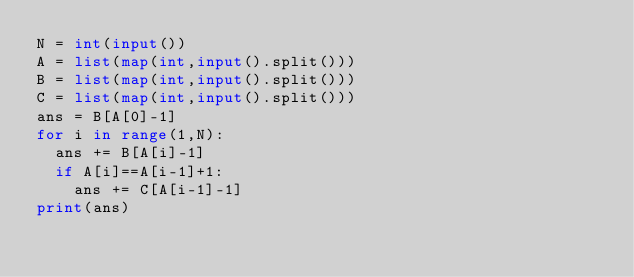Convert code to text. <code><loc_0><loc_0><loc_500><loc_500><_Python_>N = int(input())
A = list(map(int,input().split()))
B = list(map(int,input().split()))
C = list(map(int,input().split()))
ans = B[A[0]-1]
for i in range(1,N):
  ans += B[A[i]-1]
  if A[i]==A[i-1]+1:
    ans += C[A[i-1]-1]
print(ans)</code> 